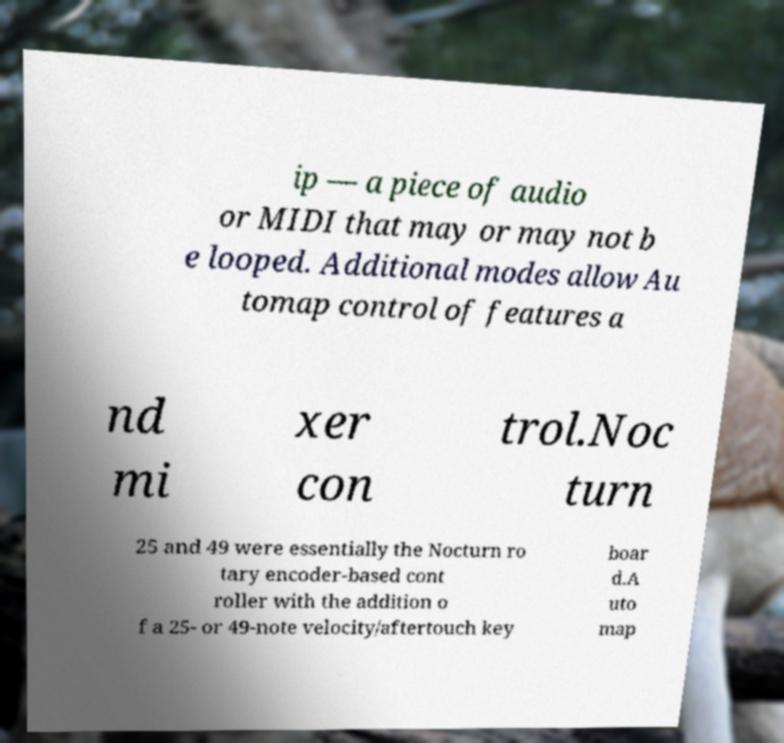Could you extract and type out the text from this image? ip — a piece of audio or MIDI that may or may not b e looped. Additional modes allow Au tomap control of features a nd mi xer con trol.Noc turn 25 and 49 were essentially the Nocturn ro tary encoder-based cont roller with the addition o f a 25- or 49-note velocity/aftertouch key boar d.A uto map 